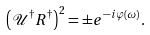<formula> <loc_0><loc_0><loc_500><loc_500>\left ( \mathcal { U } ^ { \dag } R ^ { \dag } \right ) ^ { 2 } = \pm e ^ { - i \varphi ( \omega ) } .</formula> 